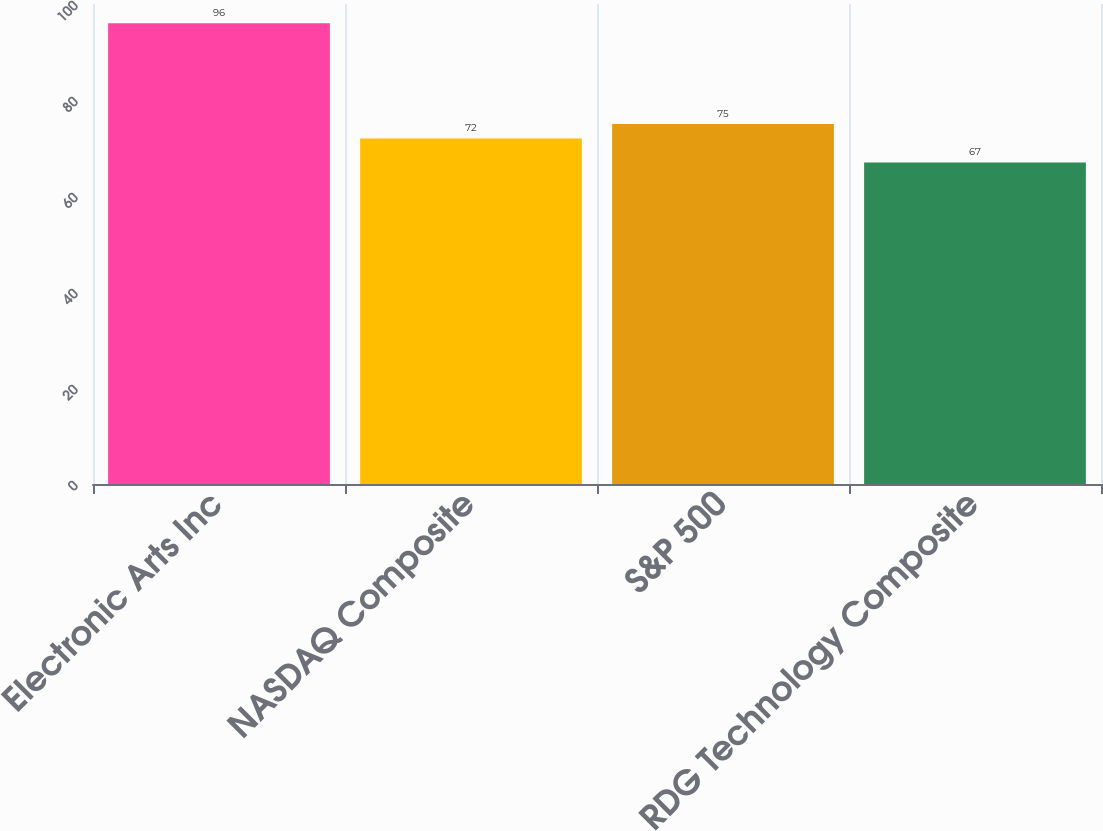<chart> <loc_0><loc_0><loc_500><loc_500><bar_chart><fcel>Electronic Arts Inc<fcel>NASDAQ Composite<fcel>S&P 500<fcel>RDG Technology Composite<nl><fcel>96<fcel>72<fcel>75<fcel>67<nl></chart> 